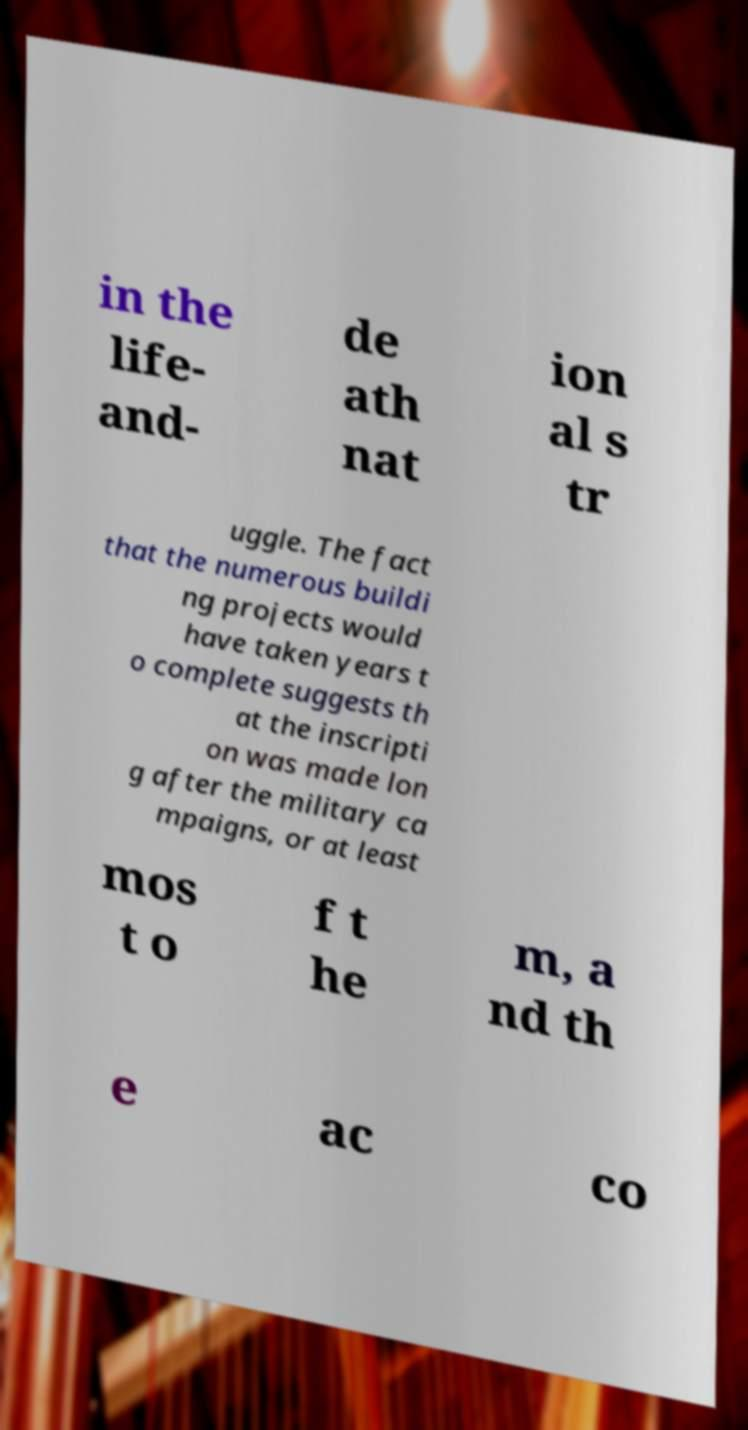Could you extract and type out the text from this image? in the life- and- de ath nat ion al s tr uggle. The fact that the numerous buildi ng projects would have taken years t o complete suggests th at the inscripti on was made lon g after the military ca mpaigns, or at least mos t o f t he m, a nd th e ac co 